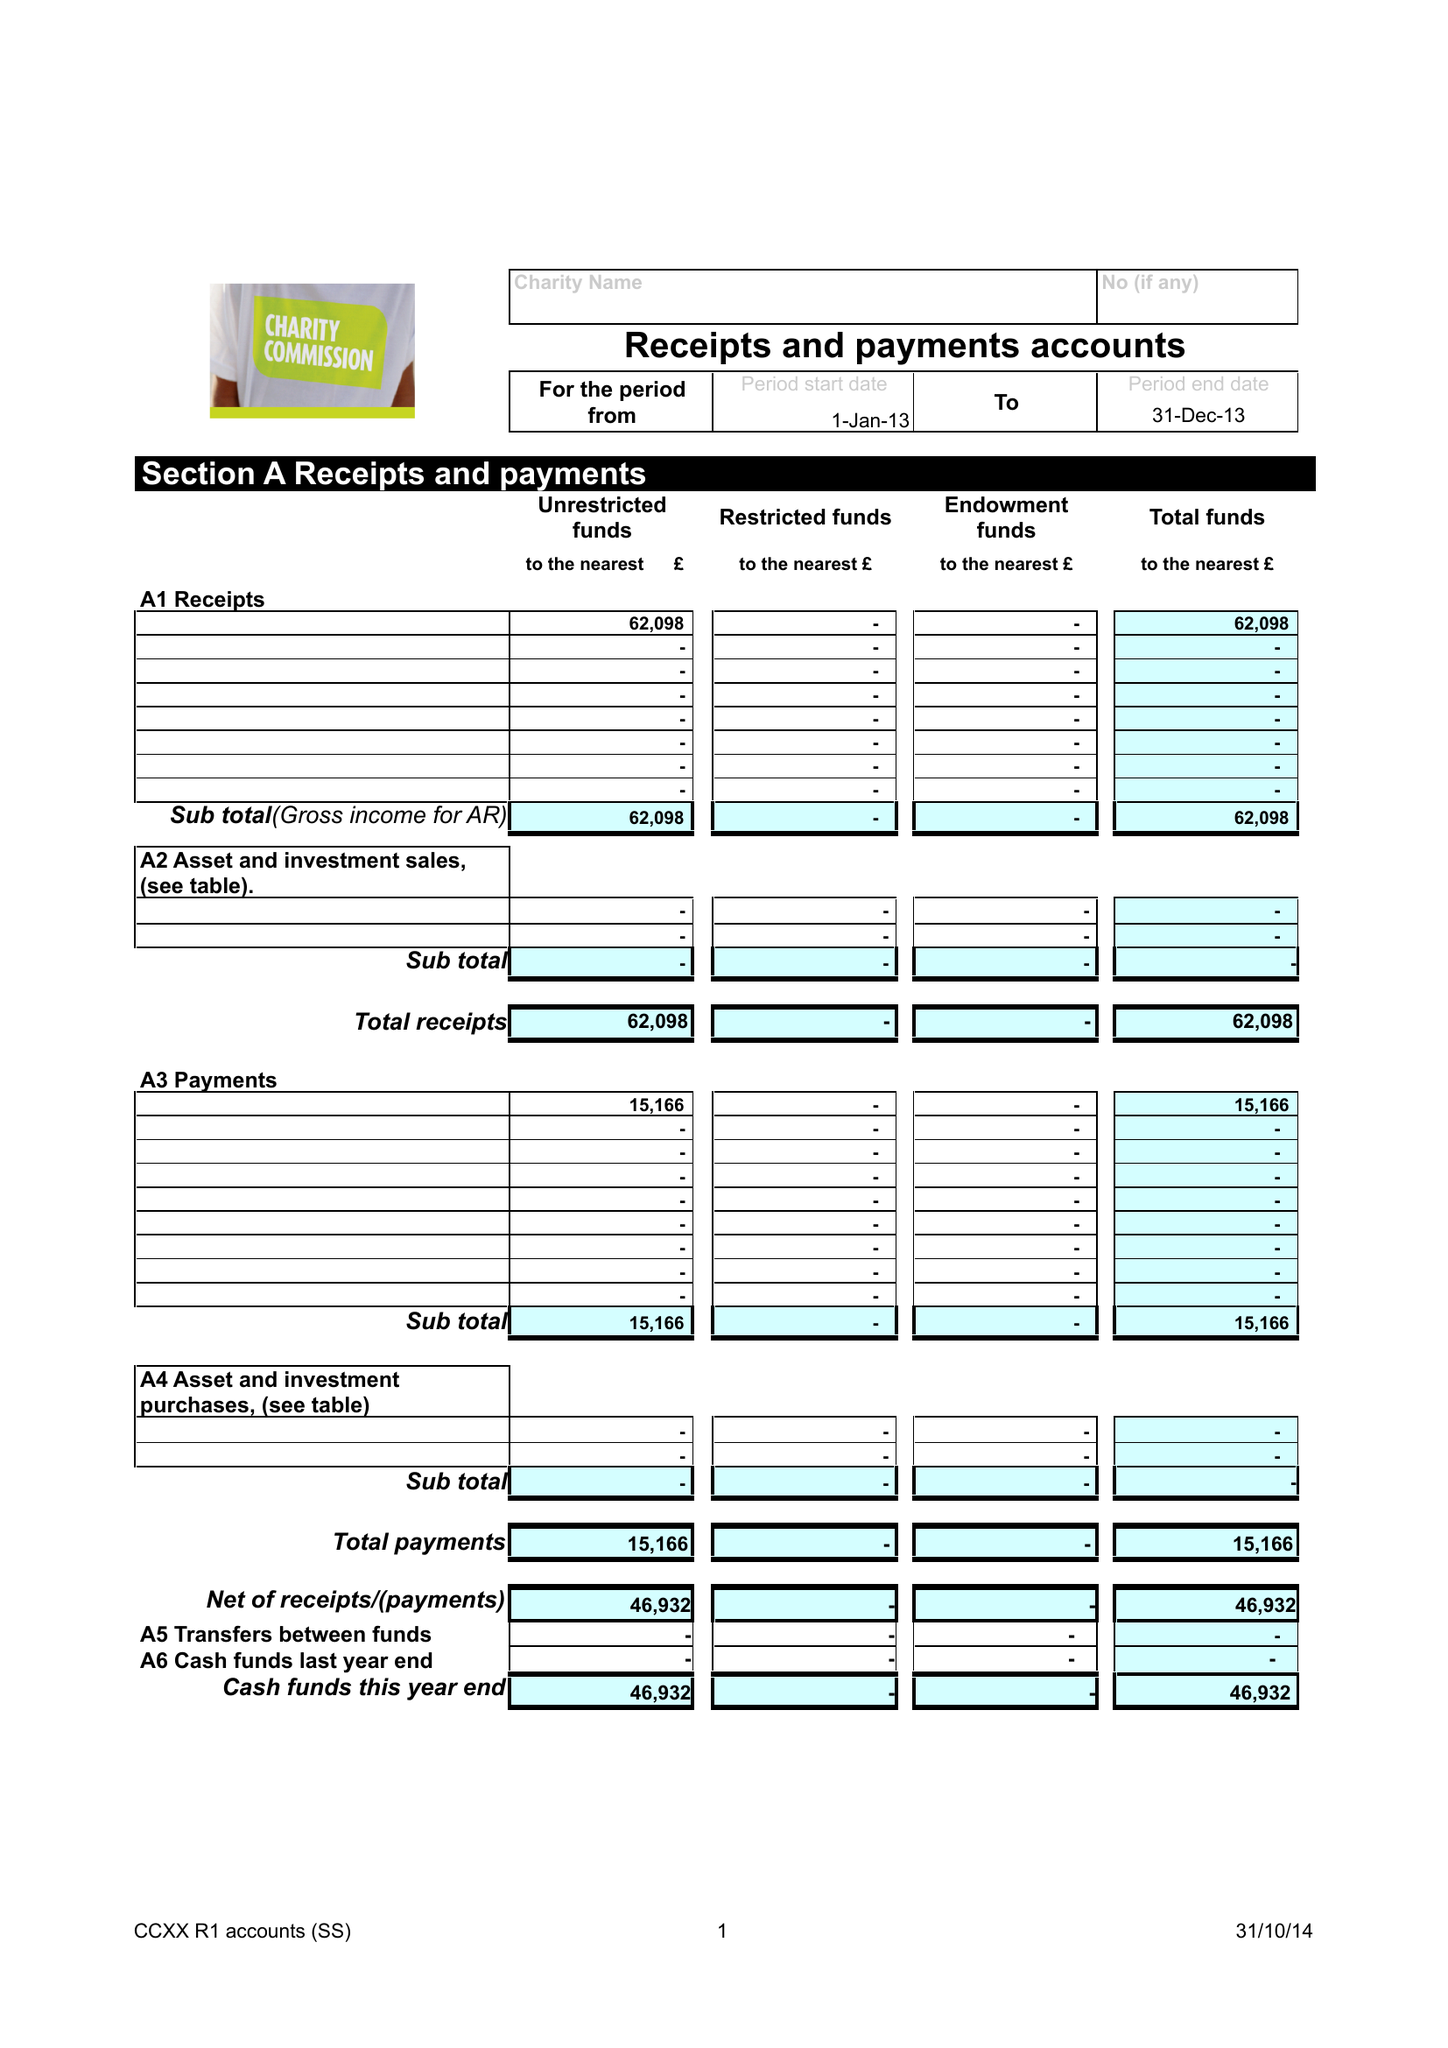What is the value for the charity_number?
Answer the question using a single word or phrase. 1002715 